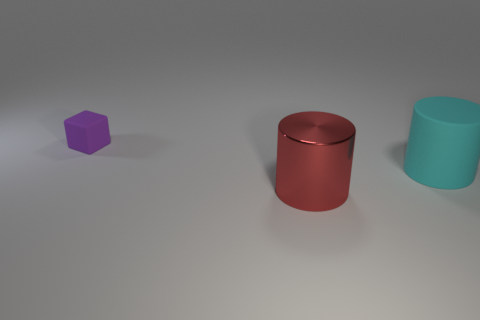Add 2 big green rubber spheres. How many objects exist? 5 Subtract all cyan cylinders. How many cylinders are left? 1 Subtract all yellow cylinders. Subtract all red blocks. How many cylinders are left? 2 Subtract all cyan spheres. How many green blocks are left? 0 Subtract all tiny matte cubes. Subtract all purple shiny blocks. How many objects are left? 2 Add 2 tiny cubes. How many tiny cubes are left? 3 Add 1 blue balls. How many blue balls exist? 1 Subtract 0 purple cylinders. How many objects are left? 3 Subtract all cylinders. How many objects are left? 1 